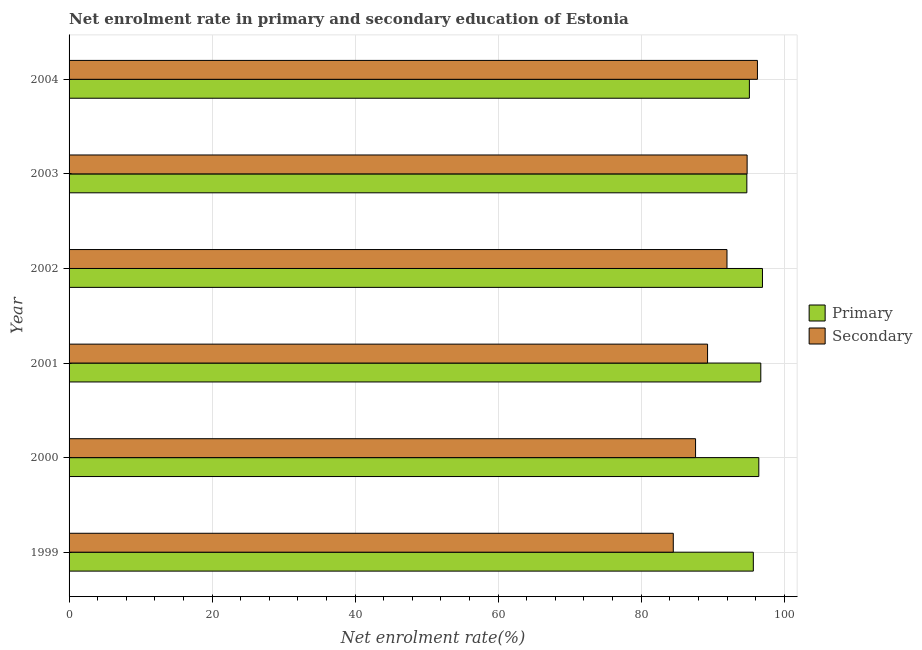Are the number of bars per tick equal to the number of legend labels?
Your answer should be compact. Yes. Are the number of bars on each tick of the Y-axis equal?
Keep it short and to the point. Yes. How many bars are there on the 3rd tick from the bottom?
Provide a short and direct response. 2. In how many cases, is the number of bars for a given year not equal to the number of legend labels?
Offer a terse response. 0. What is the enrollment rate in primary education in 2004?
Your response must be concise. 95.13. Across all years, what is the maximum enrollment rate in primary education?
Your answer should be very brief. 96.96. Across all years, what is the minimum enrollment rate in secondary education?
Provide a short and direct response. 84.49. In which year was the enrollment rate in secondary education maximum?
Your response must be concise. 2004. In which year was the enrollment rate in secondary education minimum?
Keep it short and to the point. 1999. What is the total enrollment rate in secondary education in the graph?
Offer a very short reply. 544.44. What is the difference between the enrollment rate in secondary education in 2002 and that in 2003?
Your response must be concise. -2.82. What is the difference between the enrollment rate in primary education in 2000 and the enrollment rate in secondary education in 2001?
Offer a very short reply. 7.17. What is the average enrollment rate in primary education per year?
Your answer should be compact. 95.95. In the year 1999, what is the difference between the enrollment rate in secondary education and enrollment rate in primary education?
Provide a short and direct response. -11.19. In how many years, is the enrollment rate in secondary education greater than 20 %?
Offer a very short reply. 6. What is the ratio of the enrollment rate in primary education in 1999 to that in 2003?
Give a very brief answer. 1.01. Is the enrollment rate in secondary education in 2001 less than that in 2004?
Your answer should be compact. Yes. What is the difference between the highest and the second highest enrollment rate in primary education?
Offer a terse response. 0.23. What is the difference between the highest and the lowest enrollment rate in secondary education?
Your response must be concise. 11.77. In how many years, is the enrollment rate in primary education greater than the average enrollment rate in primary education taken over all years?
Give a very brief answer. 3. Is the sum of the enrollment rate in primary education in 2000 and 2004 greater than the maximum enrollment rate in secondary education across all years?
Provide a succinct answer. Yes. What does the 2nd bar from the top in 2000 represents?
Offer a terse response. Primary. What does the 1st bar from the bottom in 2001 represents?
Your answer should be very brief. Primary. How many bars are there?
Your response must be concise. 12. How many legend labels are there?
Ensure brevity in your answer.  2. What is the title of the graph?
Offer a terse response. Net enrolment rate in primary and secondary education of Estonia. Does "Total Population" appear as one of the legend labels in the graph?
Ensure brevity in your answer.  No. What is the label or title of the X-axis?
Your answer should be compact. Net enrolment rate(%). What is the label or title of the Y-axis?
Your answer should be compact. Year. What is the Net enrolment rate(%) of Primary in 1999?
Ensure brevity in your answer.  95.68. What is the Net enrolment rate(%) in Secondary in 1999?
Your response must be concise. 84.49. What is the Net enrolment rate(%) in Primary in 2000?
Keep it short and to the point. 96.45. What is the Net enrolment rate(%) in Secondary in 2000?
Your answer should be very brief. 87.6. What is the Net enrolment rate(%) in Primary in 2001?
Offer a terse response. 96.73. What is the Net enrolment rate(%) in Secondary in 2001?
Your response must be concise. 89.28. What is the Net enrolment rate(%) of Primary in 2002?
Give a very brief answer. 96.96. What is the Net enrolment rate(%) in Secondary in 2002?
Make the answer very short. 92. What is the Net enrolment rate(%) of Primary in 2003?
Give a very brief answer. 94.77. What is the Net enrolment rate(%) of Secondary in 2003?
Offer a terse response. 94.81. What is the Net enrolment rate(%) of Primary in 2004?
Your answer should be very brief. 95.13. What is the Net enrolment rate(%) of Secondary in 2004?
Ensure brevity in your answer.  96.26. Across all years, what is the maximum Net enrolment rate(%) of Primary?
Give a very brief answer. 96.96. Across all years, what is the maximum Net enrolment rate(%) of Secondary?
Provide a short and direct response. 96.26. Across all years, what is the minimum Net enrolment rate(%) of Primary?
Your response must be concise. 94.77. Across all years, what is the minimum Net enrolment rate(%) of Secondary?
Give a very brief answer. 84.49. What is the total Net enrolment rate(%) of Primary in the graph?
Ensure brevity in your answer.  575.72. What is the total Net enrolment rate(%) of Secondary in the graph?
Offer a terse response. 544.44. What is the difference between the Net enrolment rate(%) of Primary in 1999 and that in 2000?
Offer a very short reply. -0.77. What is the difference between the Net enrolment rate(%) in Secondary in 1999 and that in 2000?
Keep it short and to the point. -3.11. What is the difference between the Net enrolment rate(%) in Primary in 1999 and that in 2001?
Ensure brevity in your answer.  -1.05. What is the difference between the Net enrolment rate(%) of Secondary in 1999 and that in 2001?
Provide a short and direct response. -4.79. What is the difference between the Net enrolment rate(%) of Primary in 1999 and that in 2002?
Keep it short and to the point. -1.28. What is the difference between the Net enrolment rate(%) of Secondary in 1999 and that in 2002?
Offer a terse response. -7.51. What is the difference between the Net enrolment rate(%) in Primary in 1999 and that in 2003?
Keep it short and to the point. 0.91. What is the difference between the Net enrolment rate(%) of Secondary in 1999 and that in 2003?
Provide a short and direct response. -10.32. What is the difference between the Net enrolment rate(%) in Primary in 1999 and that in 2004?
Offer a very short reply. 0.55. What is the difference between the Net enrolment rate(%) in Secondary in 1999 and that in 2004?
Make the answer very short. -11.77. What is the difference between the Net enrolment rate(%) in Primary in 2000 and that in 2001?
Offer a very short reply. -0.28. What is the difference between the Net enrolment rate(%) in Secondary in 2000 and that in 2001?
Keep it short and to the point. -1.68. What is the difference between the Net enrolment rate(%) of Primary in 2000 and that in 2002?
Your response must be concise. -0.51. What is the difference between the Net enrolment rate(%) in Secondary in 2000 and that in 2002?
Provide a short and direct response. -4.39. What is the difference between the Net enrolment rate(%) in Primary in 2000 and that in 2003?
Your answer should be very brief. 1.67. What is the difference between the Net enrolment rate(%) of Secondary in 2000 and that in 2003?
Your response must be concise. -7.21. What is the difference between the Net enrolment rate(%) of Primary in 2000 and that in 2004?
Provide a succinct answer. 1.32. What is the difference between the Net enrolment rate(%) of Secondary in 2000 and that in 2004?
Make the answer very short. -8.65. What is the difference between the Net enrolment rate(%) of Primary in 2001 and that in 2002?
Your answer should be compact. -0.23. What is the difference between the Net enrolment rate(%) of Secondary in 2001 and that in 2002?
Your response must be concise. -2.71. What is the difference between the Net enrolment rate(%) of Primary in 2001 and that in 2003?
Make the answer very short. 1.95. What is the difference between the Net enrolment rate(%) in Secondary in 2001 and that in 2003?
Your answer should be compact. -5.53. What is the difference between the Net enrolment rate(%) of Primary in 2001 and that in 2004?
Your answer should be compact. 1.6. What is the difference between the Net enrolment rate(%) of Secondary in 2001 and that in 2004?
Keep it short and to the point. -6.97. What is the difference between the Net enrolment rate(%) in Primary in 2002 and that in 2003?
Offer a very short reply. 2.18. What is the difference between the Net enrolment rate(%) in Secondary in 2002 and that in 2003?
Give a very brief answer. -2.82. What is the difference between the Net enrolment rate(%) in Primary in 2002 and that in 2004?
Ensure brevity in your answer.  1.83. What is the difference between the Net enrolment rate(%) of Secondary in 2002 and that in 2004?
Make the answer very short. -4.26. What is the difference between the Net enrolment rate(%) of Primary in 2003 and that in 2004?
Ensure brevity in your answer.  -0.36. What is the difference between the Net enrolment rate(%) of Secondary in 2003 and that in 2004?
Your response must be concise. -1.44. What is the difference between the Net enrolment rate(%) of Primary in 1999 and the Net enrolment rate(%) of Secondary in 2000?
Provide a succinct answer. 8.08. What is the difference between the Net enrolment rate(%) of Primary in 1999 and the Net enrolment rate(%) of Secondary in 2001?
Keep it short and to the point. 6.4. What is the difference between the Net enrolment rate(%) in Primary in 1999 and the Net enrolment rate(%) in Secondary in 2002?
Offer a very short reply. 3.68. What is the difference between the Net enrolment rate(%) of Primary in 1999 and the Net enrolment rate(%) of Secondary in 2003?
Provide a short and direct response. 0.87. What is the difference between the Net enrolment rate(%) in Primary in 1999 and the Net enrolment rate(%) in Secondary in 2004?
Provide a succinct answer. -0.58. What is the difference between the Net enrolment rate(%) in Primary in 2000 and the Net enrolment rate(%) in Secondary in 2001?
Offer a terse response. 7.17. What is the difference between the Net enrolment rate(%) in Primary in 2000 and the Net enrolment rate(%) in Secondary in 2002?
Offer a terse response. 4.45. What is the difference between the Net enrolment rate(%) in Primary in 2000 and the Net enrolment rate(%) in Secondary in 2003?
Your response must be concise. 1.63. What is the difference between the Net enrolment rate(%) in Primary in 2000 and the Net enrolment rate(%) in Secondary in 2004?
Your answer should be compact. 0.19. What is the difference between the Net enrolment rate(%) in Primary in 2001 and the Net enrolment rate(%) in Secondary in 2002?
Provide a succinct answer. 4.73. What is the difference between the Net enrolment rate(%) of Primary in 2001 and the Net enrolment rate(%) of Secondary in 2003?
Provide a succinct answer. 1.91. What is the difference between the Net enrolment rate(%) in Primary in 2001 and the Net enrolment rate(%) in Secondary in 2004?
Provide a short and direct response. 0.47. What is the difference between the Net enrolment rate(%) of Primary in 2002 and the Net enrolment rate(%) of Secondary in 2003?
Keep it short and to the point. 2.15. What is the difference between the Net enrolment rate(%) in Primary in 2002 and the Net enrolment rate(%) in Secondary in 2004?
Ensure brevity in your answer.  0.7. What is the difference between the Net enrolment rate(%) in Primary in 2003 and the Net enrolment rate(%) in Secondary in 2004?
Ensure brevity in your answer.  -1.48. What is the average Net enrolment rate(%) of Primary per year?
Your answer should be very brief. 95.95. What is the average Net enrolment rate(%) in Secondary per year?
Offer a very short reply. 90.74. In the year 1999, what is the difference between the Net enrolment rate(%) in Primary and Net enrolment rate(%) in Secondary?
Offer a terse response. 11.19. In the year 2000, what is the difference between the Net enrolment rate(%) in Primary and Net enrolment rate(%) in Secondary?
Provide a succinct answer. 8.85. In the year 2001, what is the difference between the Net enrolment rate(%) in Primary and Net enrolment rate(%) in Secondary?
Your answer should be compact. 7.44. In the year 2002, what is the difference between the Net enrolment rate(%) in Primary and Net enrolment rate(%) in Secondary?
Offer a terse response. 4.96. In the year 2003, what is the difference between the Net enrolment rate(%) of Primary and Net enrolment rate(%) of Secondary?
Your answer should be very brief. -0.04. In the year 2004, what is the difference between the Net enrolment rate(%) of Primary and Net enrolment rate(%) of Secondary?
Offer a very short reply. -1.13. What is the ratio of the Net enrolment rate(%) of Secondary in 1999 to that in 2000?
Give a very brief answer. 0.96. What is the ratio of the Net enrolment rate(%) of Secondary in 1999 to that in 2001?
Provide a succinct answer. 0.95. What is the ratio of the Net enrolment rate(%) in Primary in 1999 to that in 2002?
Provide a succinct answer. 0.99. What is the ratio of the Net enrolment rate(%) in Secondary in 1999 to that in 2002?
Your answer should be compact. 0.92. What is the ratio of the Net enrolment rate(%) in Primary in 1999 to that in 2003?
Provide a short and direct response. 1.01. What is the ratio of the Net enrolment rate(%) in Secondary in 1999 to that in 2003?
Offer a terse response. 0.89. What is the ratio of the Net enrolment rate(%) of Primary in 1999 to that in 2004?
Provide a succinct answer. 1.01. What is the ratio of the Net enrolment rate(%) of Secondary in 1999 to that in 2004?
Provide a short and direct response. 0.88. What is the ratio of the Net enrolment rate(%) in Primary in 2000 to that in 2001?
Your response must be concise. 1. What is the ratio of the Net enrolment rate(%) of Secondary in 2000 to that in 2001?
Your answer should be compact. 0.98. What is the ratio of the Net enrolment rate(%) of Primary in 2000 to that in 2002?
Your response must be concise. 0.99. What is the ratio of the Net enrolment rate(%) in Secondary in 2000 to that in 2002?
Offer a terse response. 0.95. What is the ratio of the Net enrolment rate(%) of Primary in 2000 to that in 2003?
Provide a short and direct response. 1.02. What is the ratio of the Net enrolment rate(%) of Secondary in 2000 to that in 2003?
Your answer should be very brief. 0.92. What is the ratio of the Net enrolment rate(%) of Primary in 2000 to that in 2004?
Give a very brief answer. 1.01. What is the ratio of the Net enrolment rate(%) in Secondary in 2000 to that in 2004?
Ensure brevity in your answer.  0.91. What is the ratio of the Net enrolment rate(%) in Secondary in 2001 to that in 2002?
Ensure brevity in your answer.  0.97. What is the ratio of the Net enrolment rate(%) of Primary in 2001 to that in 2003?
Provide a succinct answer. 1.02. What is the ratio of the Net enrolment rate(%) in Secondary in 2001 to that in 2003?
Provide a succinct answer. 0.94. What is the ratio of the Net enrolment rate(%) of Primary in 2001 to that in 2004?
Ensure brevity in your answer.  1.02. What is the ratio of the Net enrolment rate(%) in Secondary in 2001 to that in 2004?
Provide a succinct answer. 0.93. What is the ratio of the Net enrolment rate(%) in Secondary in 2002 to that in 2003?
Provide a short and direct response. 0.97. What is the ratio of the Net enrolment rate(%) of Primary in 2002 to that in 2004?
Offer a very short reply. 1.02. What is the ratio of the Net enrolment rate(%) of Secondary in 2002 to that in 2004?
Offer a terse response. 0.96. What is the ratio of the Net enrolment rate(%) of Primary in 2003 to that in 2004?
Your answer should be compact. 1. What is the difference between the highest and the second highest Net enrolment rate(%) in Primary?
Keep it short and to the point. 0.23. What is the difference between the highest and the second highest Net enrolment rate(%) in Secondary?
Ensure brevity in your answer.  1.44. What is the difference between the highest and the lowest Net enrolment rate(%) of Primary?
Your response must be concise. 2.18. What is the difference between the highest and the lowest Net enrolment rate(%) of Secondary?
Offer a terse response. 11.77. 